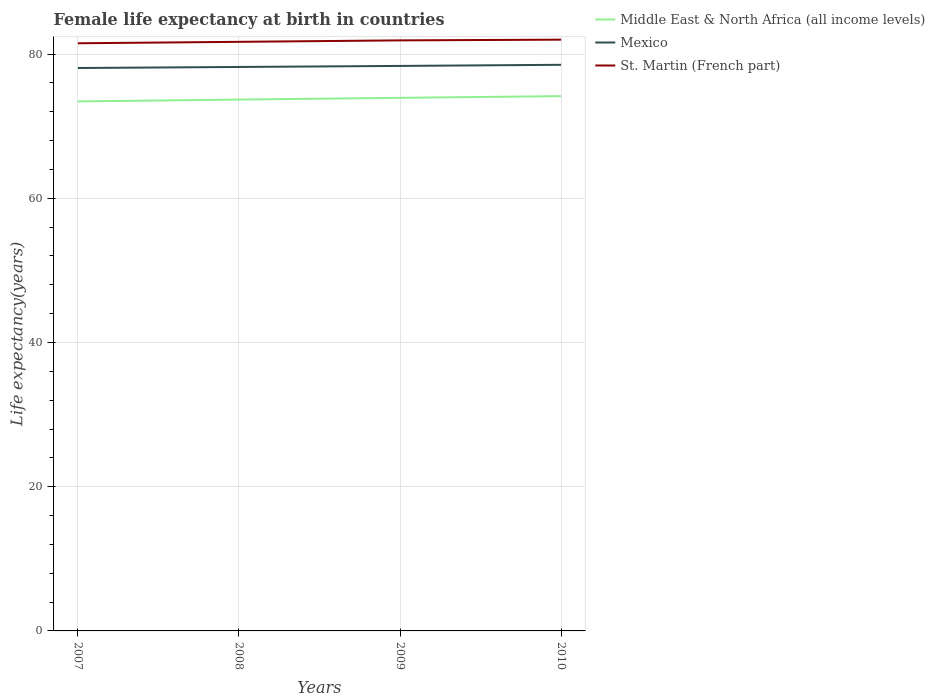How many different coloured lines are there?
Provide a succinct answer. 3. Does the line corresponding to Middle East & North Africa (all income levels) intersect with the line corresponding to Mexico?
Provide a short and direct response. No. Across all years, what is the maximum female life expectancy at birth in Mexico?
Your answer should be compact. 78.07. What is the total female life expectancy at birth in Middle East & North Africa (all income levels) in the graph?
Your answer should be compact. -0.24. What is the difference between the highest and the second highest female life expectancy at birth in Middle East & North Africa (all income levels)?
Ensure brevity in your answer.  0.73. What is the difference between two consecutive major ticks on the Y-axis?
Offer a very short reply. 20. Are the values on the major ticks of Y-axis written in scientific E-notation?
Provide a succinct answer. No. Does the graph contain any zero values?
Provide a short and direct response. No. Where does the legend appear in the graph?
Ensure brevity in your answer.  Top right. How are the legend labels stacked?
Offer a terse response. Vertical. What is the title of the graph?
Give a very brief answer. Female life expectancy at birth in countries. Does "Mexico" appear as one of the legend labels in the graph?
Provide a succinct answer. Yes. What is the label or title of the Y-axis?
Ensure brevity in your answer.  Life expectancy(years). What is the Life expectancy(years) in Middle East & North Africa (all income levels) in 2007?
Give a very brief answer. 73.44. What is the Life expectancy(years) in Mexico in 2007?
Your answer should be very brief. 78.07. What is the Life expectancy(years) of St. Martin (French part) in 2007?
Offer a very short reply. 81.5. What is the Life expectancy(years) of Middle East & North Africa (all income levels) in 2008?
Give a very brief answer. 73.69. What is the Life expectancy(years) of Mexico in 2008?
Your response must be concise. 78.21. What is the Life expectancy(years) of St. Martin (French part) in 2008?
Your answer should be compact. 81.7. What is the Life expectancy(years) of Middle East & North Africa (all income levels) in 2009?
Offer a terse response. 73.93. What is the Life expectancy(years) of Mexico in 2009?
Keep it short and to the point. 78.36. What is the Life expectancy(years) of St. Martin (French part) in 2009?
Your answer should be compact. 81.9. What is the Life expectancy(years) of Middle East & North Africa (all income levels) in 2010?
Your answer should be very brief. 74.17. What is the Life expectancy(years) of Mexico in 2010?
Provide a succinct answer. 78.51. What is the Life expectancy(years) of St. Martin (French part) in 2010?
Your response must be concise. 82. Across all years, what is the maximum Life expectancy(years) in Middle East & North Africa (all income levels)?
Make the answer very short. 74.17. Across all years, what is the maximum Life expectancy(years) in Mexico?
Make the answer very short. 78.51. Across all years, what is the maximum Life expectancy(years) in St. Martin (French part)?
Your answer should be very brief. 82. Across all years, what is the minimum Life expectancy(years) in Middle East & North Africa (all income levels)?
Your answer should be compact. 73.44. Across all years, what is the minimum Life expectancy(years) of Mexico?
Offer a very short reply. 78.07. Across all years, what is the minimum Life expectancy(years) in St. Martin (French part)?
Keep it short and to the point. 81.5. What is the total Life expectancy(years) in Middle East & North Africa (all income levels) in the graph?
Your response must be concise. 295.23. What is the total Life expectancy(years) of Mexico in the graph?
Provide a succinct answer. 313.15. What is the total Life expectancy(years) in St. Martin (French part) in the graph?
Your answer should be very brief. 327.1. What is the difference between the Life expectancy(years) in Middle East & North Africa (all income levels) in 2007 and that in 2008?
Give a very brief answer. -0.25. What is the difference between the Life expectancy(years) in Mexico in 2007 and that in 2008?
Your answer should be very brief. -0.14. What is the difference between the Life expectancy(years) in St. Martin (French part) in 2007 and that in 2008?
Make the answer very short. -0.2. What is the difference between the Life expectancy(years) of Middle East & North Africa (all income levels) in 2007 and that in 2009?
Your answer should be compact. -0.5. What is the difference between the Life expectancy(years) of Mexico in 2007 and that in 2009?
Provide a short and direct response. -0.29. What is the difference between the Life expectancy(years) in Middle East & North Africa (all income levels) in 2007 and that in 2010?
Offer a very short reply. -0.73. What is the difference between the Life expectancy(years) of Mexico in 2007 and that in 2010?
Provide a short and direct response. -0.45. What is the difference between the Life expectancy(years) of Middle East & North Africa (all income levels) in 2008 and that in 2009?
Ensure brevity in your answer.  -0.24. What is the difference between the Life expectancy(years) in Mexico in 2008 and that in 2009?
Give a very brief answer. -0.15. What is the difference between the Life expectancy(years) of Middle East & North Africa (all income levels) in 2008 and that in 2010?
Your answer should be compact. -0.48. What is the difference between the Life expectancy(years) in Mexico in 2008 and that in 2010?
Your response must be concise. -0.3. What is the difference between the Life expectancy(years) of St. Martin (French part) in 2008 and that in 2010?
Ensure brevity in your answer.  -0.3. What is the difference between the Life expectancy(years) of Middle East & North Africa (all income levels) in 2009 and that in 2010?
Your response must be concise. -0.23. What is the difference between the Life expectancy(years) of Mexico in 2009 and that in 2010?
Give a very brief answer. -0.15. What is the difference between the Life expectancy(years) in St. Martin (French part) in 2009 and that in 2010?
Your answer should be compact. -0.1. What is the difference between the Life expectancy(years) in Middle East & North Africa (all income levels) in 2007 and the Life expectancy(years) in Mexico in 2008?
Offer a very short reply. -4.77. What is the difference between the Life expectancy(years) of Middle East & North Africa (all income levels) in 2007 and the Life expectancy(years) of St. Martin (French part) in 2008?
Give a very brief answer. -8.26. What is the difference between the Life expectancy(years) of Mexico in 2007 and the Life expectancy(years) of St. Martin (French part) in 2008?
Offer a very short reply. -3.63. What is the difference between the Life expectancy(years) in Middle East & North Africa (all income levels) in 2007 and the Life expectancy(years) in Mexico in 2009?
Keep it short and to the point. -4.92. What is the difference between the Life expectancy(years) of Middle East & North Africa (all income levels) in 2007 and the Life expectancy(years) of St. Martin (French part) in 2009?
Your answer should be compact. -8.46. What is the difference between the Life expectancy(years) in Mexico in 2007 and the Life expectancy(years) in St. Martin (French part) in 2009?
Provide a succinct answer. -3.83. What is the difference between the Life expectancy(years) of Middle East & North Africa (all income levels) in 2007 and the Life expectancy(years) of Mexico in 2010?
Your answer should be very brief. -5.08. What is the difference between the Life expectancy(years) in Middle East & North Africa (all income levels) in 2007 and the Life expectancy(years) in St. Martin (French part) in 2010?
Give a very brief answer. -8.56. What is the difference between the Life expectancy(years) in Mexico in 2007 and the Life expectancy(years) in St. Martin (French part) in 2010?
Your response must be concise. -3.93. What is the difference between the Life expectancy(years) in Middle East & North Africa (all income levels) in 2008 and the Life expectancy(years) in Mexico in 2009?
Your response must be concise. -4.67. What is the difference between the Life expectancy(years) in Middle East & North Africa (all income levels) in 2008 and the Life expectancy(years) in St. Martin (French part) in 2009?
Keep it short and to the point. -8.21. What is the difference between the Life expectancy(years) of Mexico in 2008 and the Life expectancy(years) of St. Martin (French part) in 2009?
Your answer should be compact. -3.69. What is the difference between the Life expectancy(years) of Middle East & North Africa (all income levels) in 2008 and the Life expectancy(years) of Mexico in 2010?
Give a very brief answer. -4.82. What is the difference between the Life expectancy(years) in Middle East & North Africa (all income levels) in 2008 and the Life expectancy(years) in St. Martin (French part) in 2010?
Ensure brevity in your answer.  -8.31. What is the difference between the Life expectancy(years) in Mexico in 2008 and the Life expectancy(years) in St. Martin (French part) in 2010?
Provide a succinct answer. -3.79. What is the difference between the Life expectancy(years) in Middle East & North Africa (all income levels) in 2009 and the Life expectancy(years) in Mexico in 2010?
Provide a short and direct response. -4.58. What is the difference between the Life expectancy(years) of Middle East & North Africa (all income levels) in 2009 and the Life expectancy(years) of St. Martin (French part) in 2010?
Make the answer very short. -8.07. What is the difference between the Life expectancy(years) in Mexico in 2009 and the Life expectancy(years) in St. Martin (French part) in 2010?
Provide a short and direct response. -3.64. What is the average Life expectancy(years) of Middle East & North Africa (all income levels) per year?
Give a very brief answer. 73.81. What is the average Life expectancy(years) in Mexico per year?
Provide a succinct answer. 78.29. What is the average Life expectancy(years) of St. Martin (French part) per year?
Provide a succinct answer. 81.78. In the year 2007, what is the difference between the Life expectancy(years) of Middle East & North Africa (all income levels) and Life expectancy(years) of Mexico?
Provide a succinct answer. -4.63. In the year 2007, what is the difference between the Life expectancy(years) of Middle East & North Africa (all income levels) and Life expectancy(years) of St. Martin (French part)?
Your response must be concise. -8.06. In the year 2007, what is the difference between the Life expectancy(years) in Mexico and Life expectancy(years) in St. Martin (French part)?
Provide a short and direct response. -3.43. In the year 2008, what is the difference between the Life expectancy(years) of Middle East & North Africa (all income levels) and Life expectancy(years) of Mexico?
Make the answer very short. -4.52. In the year 2008, what is the difference between the Life expectancy(years) in Middle East & North Africa (all income levels) and Life expectancy(years) in St. Martin (French part)?
Make the answer very short. -8.01. In the year 2008, what is the difference between the Life expectancy(years) of Mexico and Life expectancy(years) of St. Martin (French part)?
Your answer should be compact. -3.49. In the year 2009, what is the difference between the Life expectancy(years) of Middle East & North Africa (all income levels) and Life expectancy(years) of Mexico?
Offer a very short reply. -4.43. In the year 2009, what is the difference between the Life expectancy(years) in Middle East & North Africa (all income levels) and Life expectancy(years) in St. Martin (French part)?
Make the answer very short. -7.97. In the year 2009, what is the difference between the Life expectancy(years) of Mexico and Life expectancy(years) of St. Martin (French part)?
Provide a short and direct response. -3.54. In the year 2010, what is the difference between the Life expectancy(years) in Middle East & North Africa (all income levels) and Life expectancy(years) in Mexico?
Provide a succinct answer. -4.35. In the year 2010, what is the difference between the Life expectancy(years) in Middle East & North Africa (all income levels) and Life expectancy(years) in St. Martin (French part)?
Your answer should be very brief. -7.83. In the year 2010, what is the difference between the Life expectancy(years) in Mexico and Life expectancy(years) in St. Martin (French part)?
Offer a terse response. -3.49. What is the ratio of the Life expectancy(years) in St. Martin (French part) in 2007 to that in 2008?
Your response must be concise. 1. What is the ratio of the Life expectancy(years) in Mexico in 2007 to that in 2009?
Offer a very short reply. 1. What is the ratio of the Life expectancy(years) in St. Martin (French part) in 2007 to that in 2009?
Your answer should be compact. 1. What is the ratio of the Life expectancy(years) in Middle East & North Africa (all income levels) in 2007 to that in 2010?
Offer a very short reply. 0.99. What is the ratio of the Life expectancy(years) of St. Martin (French part) in 2007 to that in 2010?
Keep it short and to the point. 0.99. What is the ratio of the Life expectancy(years) of Mexico in 2008 to that in 2009?
Your response must be concise. 1. What is the ratio of the Life expectancy(years) in St. Martin (French part) in 2008 to that in 2009?
Offer a very short reply. 1. What is the ratio of the Life expectancy(years) of Middle East & North Africa (all income levels) in 2008 to that in 2010?
Offer a terse response. 0.99. What is the ratio of the Life expectancy(years) in St. Martin (French part) in 2008 to that in 2010?
Give a very brief answer. 1. What is the ratio of the Life expectancy(years) of St. Martin (French part) in 2009 to that in 2010?
Make the answer very short. 1. What is the difference between the highest and the second highest Life expectancy(years) in Middle East & North Africa (all income levels)?
Provide a short and direct response. 0.23. What is the difference between the highest and the second highest Life expectancy(years) in Mexico?
Make the answer very short. 0.15. What is the difference between the highest and the second highest Life expectancy(years) in St. Martin (French part)?
Make the answer very short. 0.1. What is the difference between the highest and the lowest Life expectancy(years) in Middle East & North Africa (all income levels)?
Provide a succinct answer. 0.73. What is the difference between the highest and the lowest Life expectancy(years) in Mexico?
Your answer should be very brief. 0.45. What is the difference between the highest and the lowest Life expectancy(years) in St. Martin (French part)?
Your answer should be compact. 0.5. 